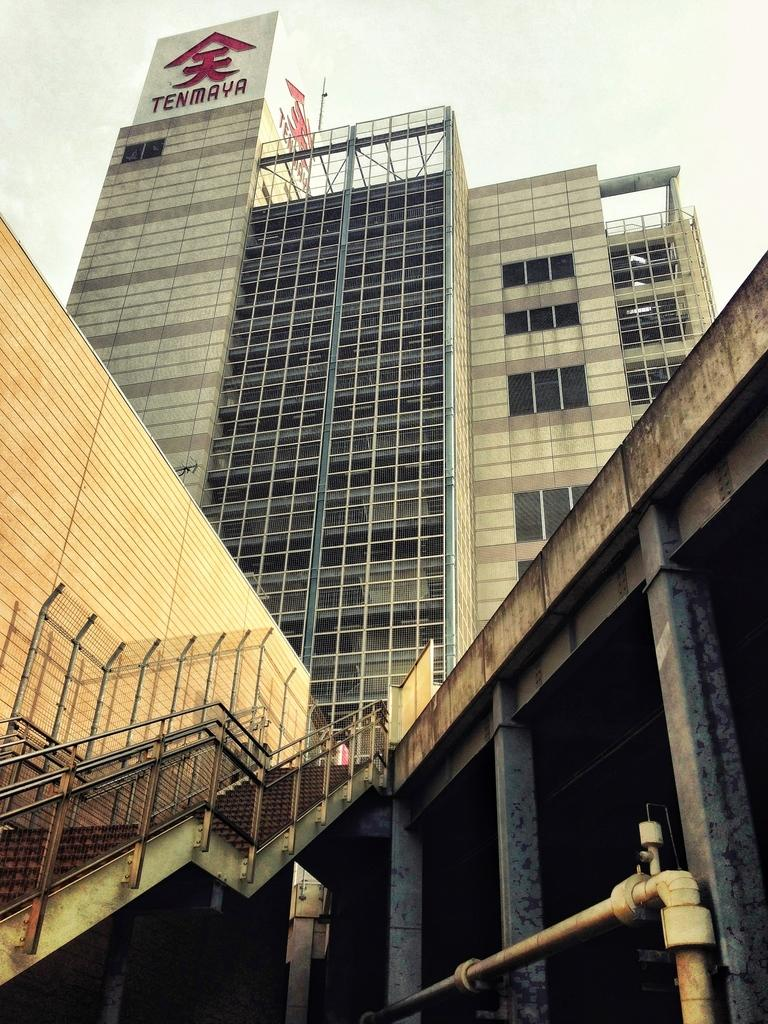What structure is the main subject of the image? There is a building in the image. What architectural features are present in front of the building? There are stairs and pillars in front of the building. What can be seen in the background of the image? The sky is visible in the background of the image. Is there a recess or bridge connecting the building to another structure in the image? No, there is no recess or bridge connecting the building to another structure in the image. Is there a camp or outdoor gathering visible in the image? No, there is no camp or outdoor gathering visible in the image. 